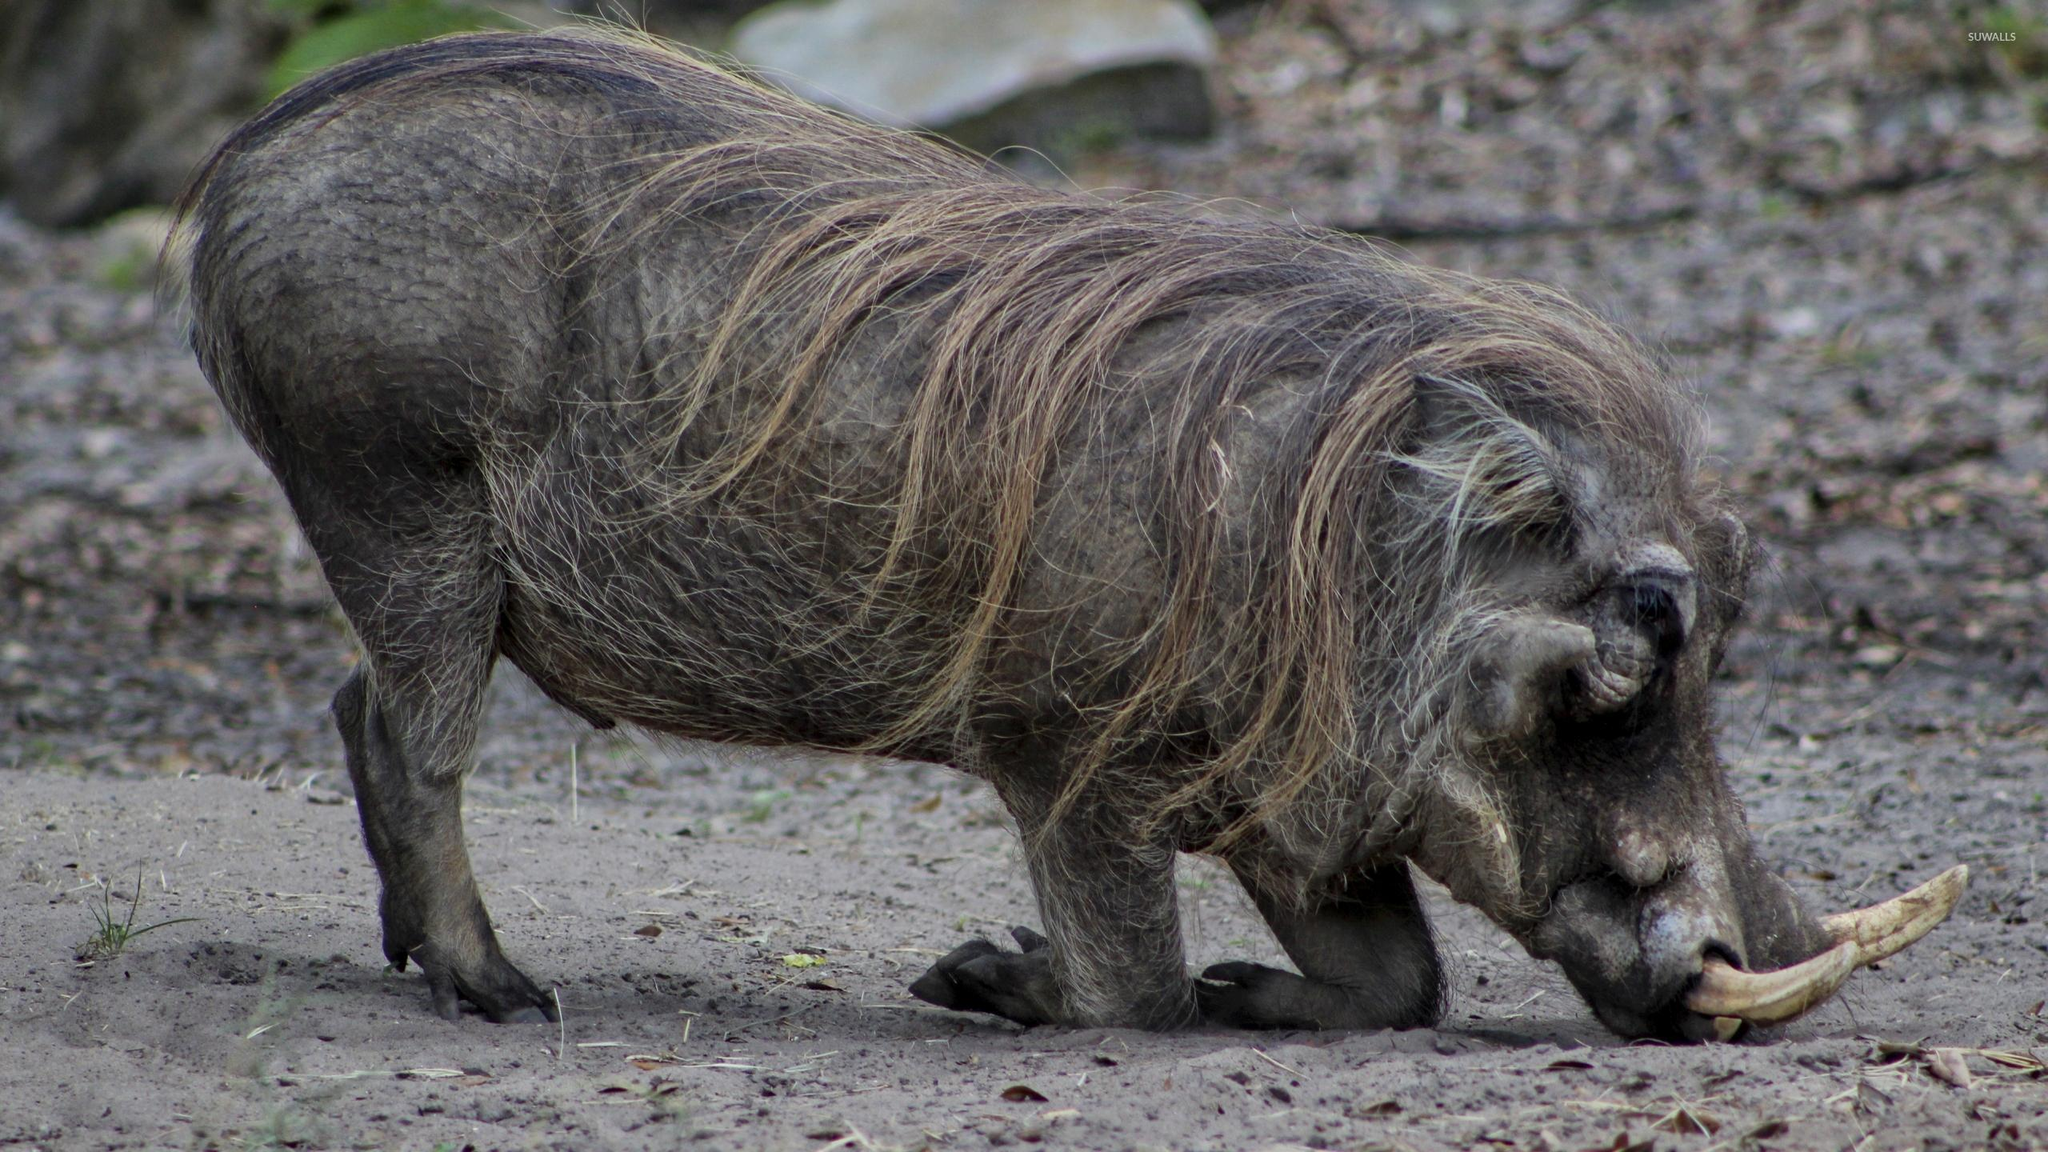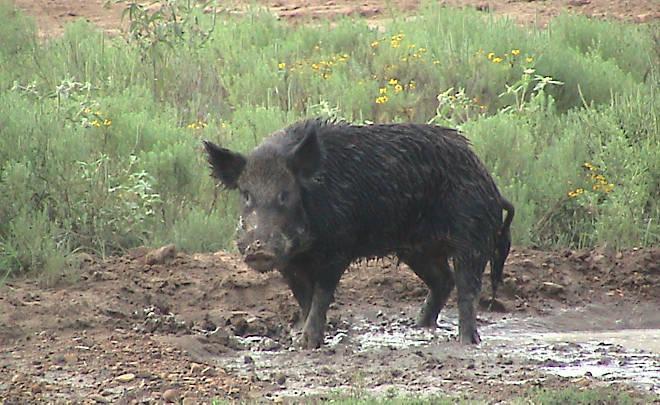The first image is the image on the left, the second image is the image on the right. Examine the images to the left and right. Is the description "There are two animals in the picture on the left." accurate? Answer yes or no. No. 